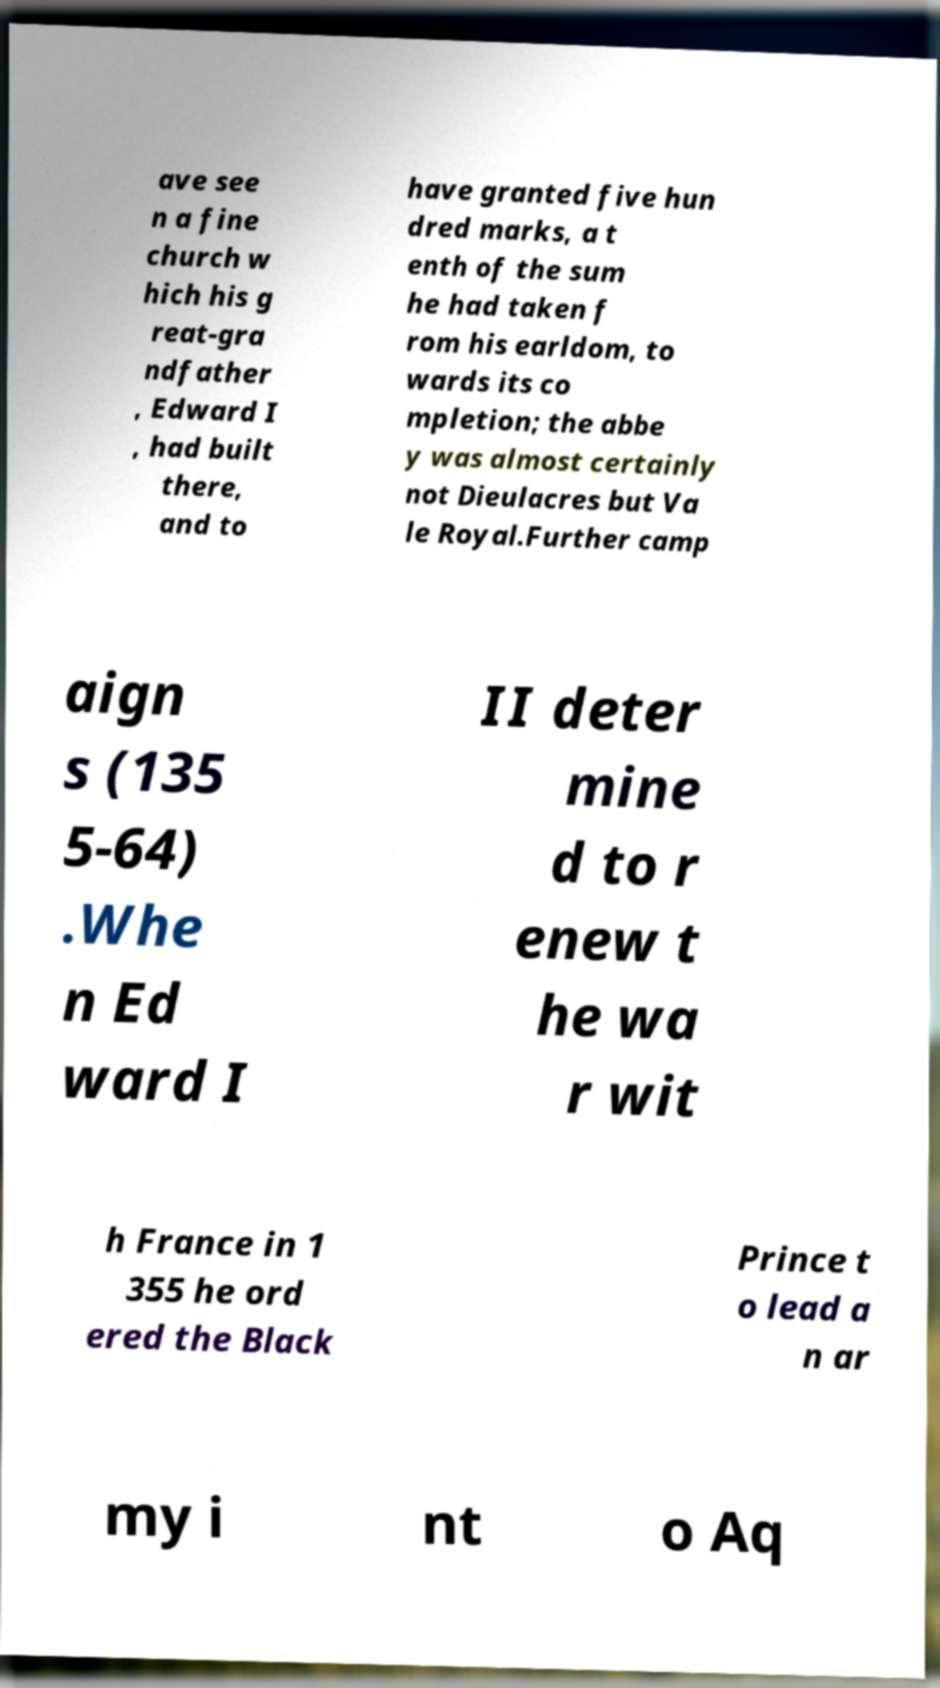Can you read and provide the text displayed in the image?This photo seems to have some interesting text. Can you extract and type it out for me? ave see n a fine church w hich his g reat-gra ndfather , Edward I , had built there, and to have granted five hun dred marks, a t enth of the sum he had taken f rom his earldom, to wards its co mpletion; the abbe y was almost certainly not Dieulacres but Va le Royal.Further camp aign s (135 5-64) .Whe n Ed ward I II deter mine d to r enew t he wa r wit h France in 1 355 he ord ered the Black Prince t o lead a n ar my i nt o Aq 